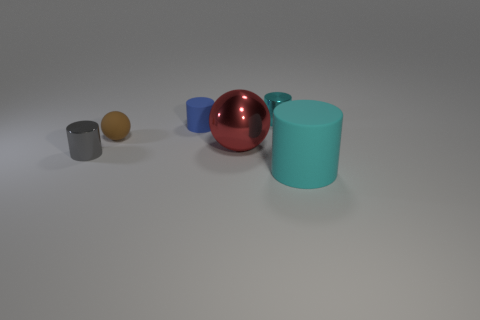Subtract all cyan spheres. How many cyan cylinders are left? 2 Subtract all gray cylinders. How many cylinders are left? 3 Subtract 1 cylinders. How many cylinders are left? 3 Add 1 brown objects. How many objects exist? 7 Subtract all gray cylinders. How many cylinders are left? 3 Subtract all balls. How many objects are left? 4 Subtract 0 red cylinders. How many objects are left? 6 Subtract all red spheres. Subtract all cyan cubes. How many spheres are left? 1 Subtract all small things. Subtract all small gray matte cylinders. How many objects are left? 2 Add 4 big red objects. How many big red objects are left? 5 